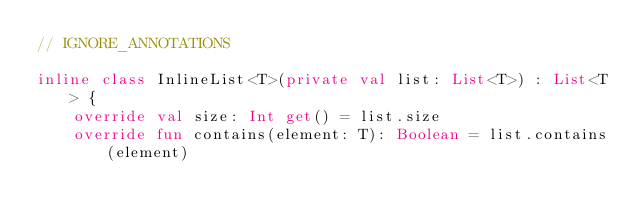Convert code to text. <code><loc_0><loc_0><loc_500><loc_500><_Kotlin_>// IGNORE_ANNOTATIONS

inline class InlineList<T>(private val list: List<T>) : List<T> {
    override val size: Int get() = list.size
    override fun contains(element: T): Boolean = list.contains(element)</code> 